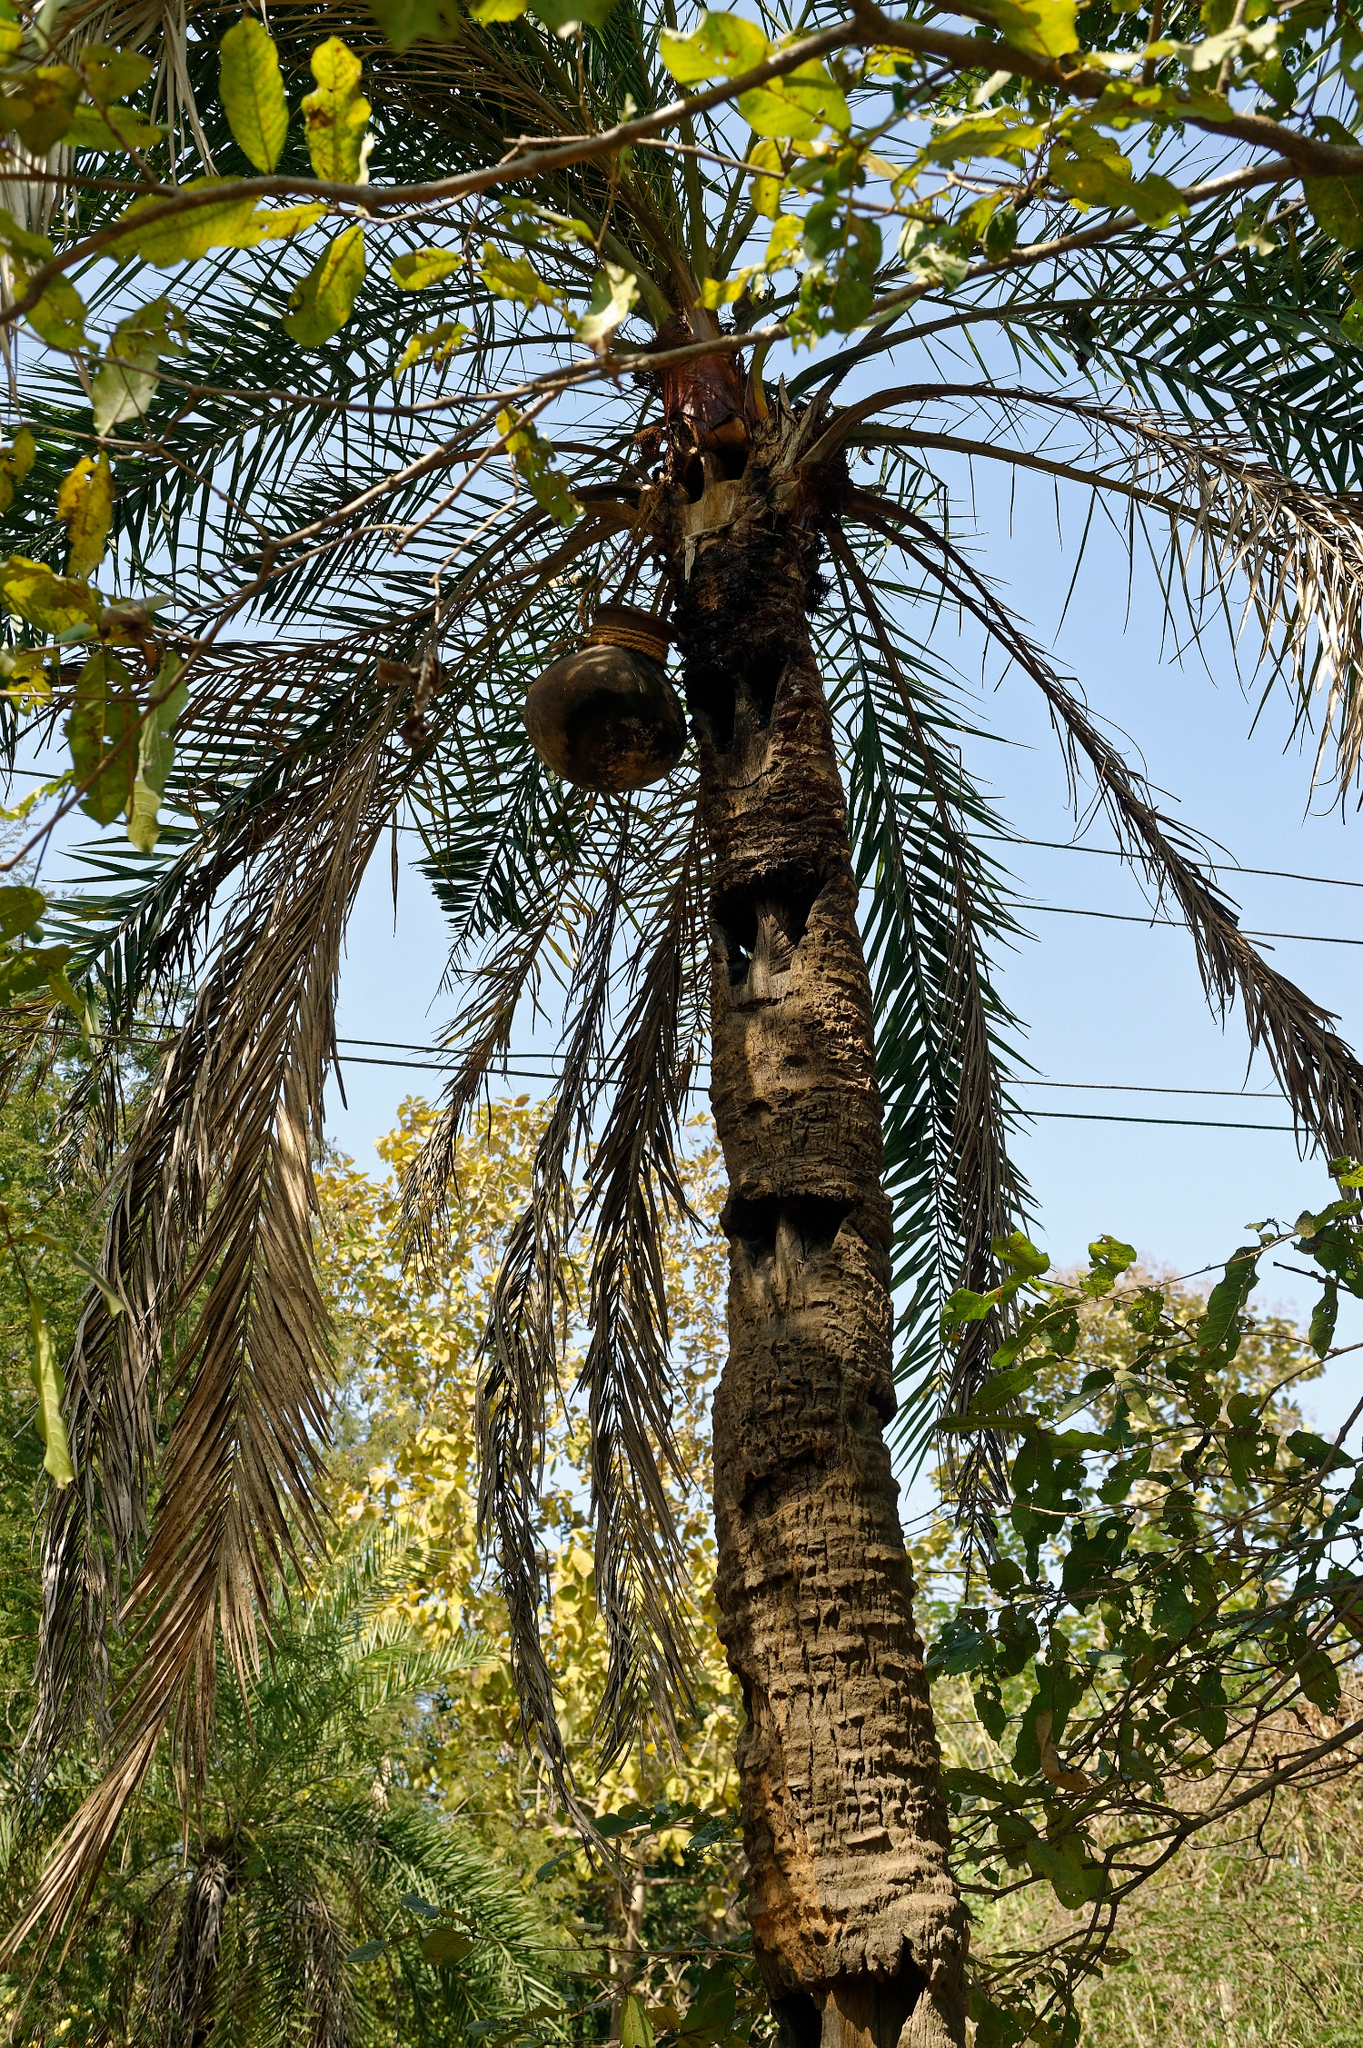If this tree could speak, what do you think it would say? If this tree could speak, it would probably share tales of resilience and survival. 'I have stood here for decades, weathering storms and basking in the sunshine,' it might say. 'I have seen birds come and go, each bringing a new story, a new melody. My bark may be rough, my leaves a blend of green and gold, but within me lies the strength of countless seasons. I offer refuge to those who seek it, and in return, I receive the songs of life. Remember, the world around us is ever-changing, yet, like me, stand firm and embrace the journey.' The tree's wisdom, gathered over years of steadfast existence, would be a reminder of the beauty and brevity of life. 